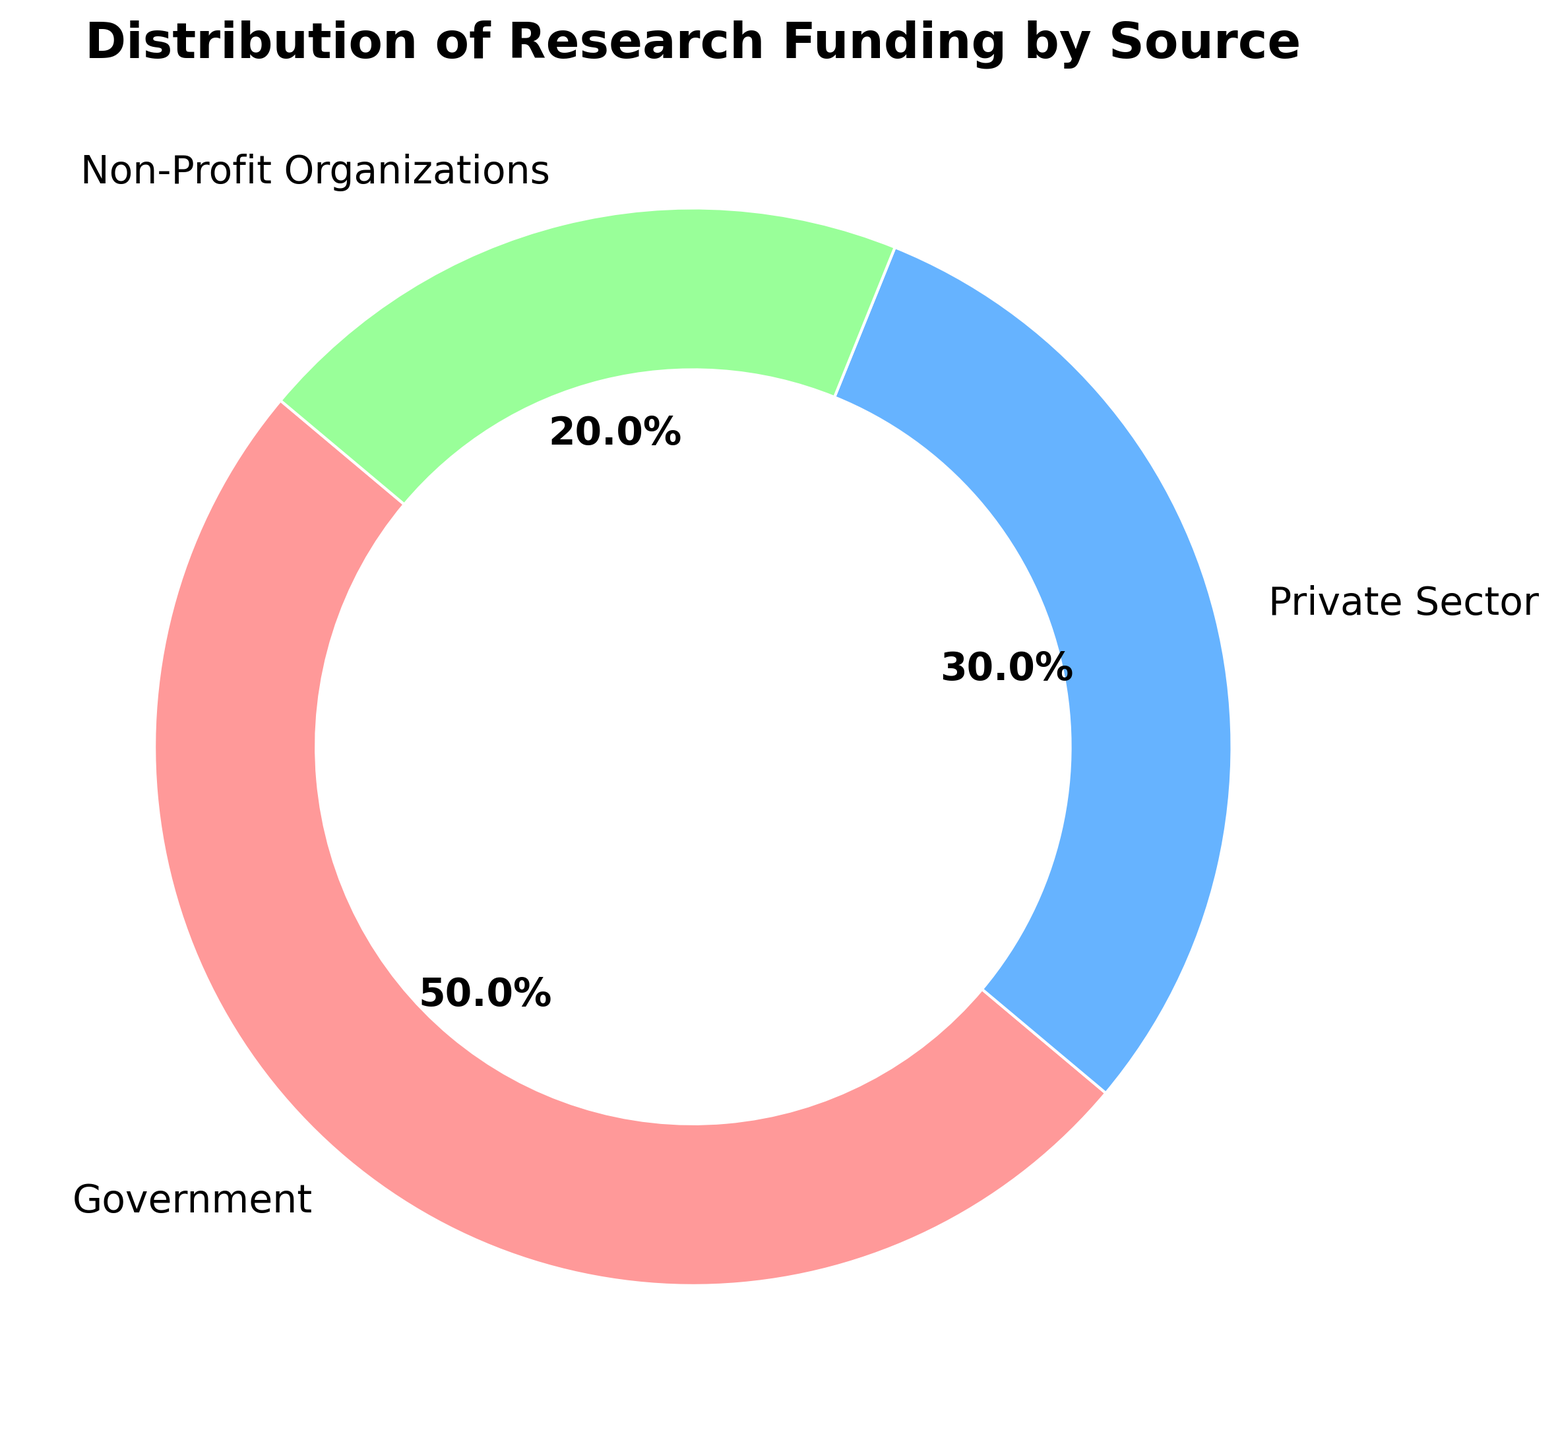What percentage of research funding comes from Government sources? The pie chart clearly shows that the largest portion of the funding, indicated in the color representing Government (most likely red or another strong color), is labeled as 50%.
Answer: 50% How much greater is the percentage of funding from Government compared to Non-Profit Organizations? From the pie chart, the Government funding is 50%, and Non-Profit Organizations funding is 20%. Subtracting the smaller percentage from the larger gives 50% - 20%.
Answer: 30% Which funding source has the smallest contribution, and what is its percentage? By observing the pie chart, we can see that the smallest segment, indicated by its size, represents Non-Profit Organizations, which is labeled as 20%.
Answer: Non-Profit Organizations, 20% If the total funding is $1,000,000, how much is contributed by the Private Sector? The pie chart shows the Private Sector contributes 30% of the funding. To find the amount: \(1{,}000{,}000 \times 0.30\).
Answer: $300,000 What is the combined percentage of funding from Private Sector and Non-Profit Organizations? Adding the percentages from the pie chart for Private Sector (30%) and Non-Profit Organizations (20%) results in 30% + 20%.
Answer: 50% Which sector has the highest funding, and by how much more is it than the Private Sector? From the pie chart, the Government has the highest funding at 50%. The Private Sector is at 30%. The difference is 50% - 30%.
Answer: Government, 20% What color visually represents the Non-Profit Organizations funding on the pie chart? By looking at the pie chart and identifying the segments, the Non-Profit Organizations segment (20%) will be marked with a specific color, likely green based on typical color-coding conventions.
Answer: Green If the total allocation for Government funding doubles next year, what percentage of the total will it then represent, assuming the total funding pool remains the same? The current Government funding is 50% of the total. If the amount doubles, it will then represent \(50\% \times 2 = 100\%\). This unrealistic scenario indicates the entire funding would be from the Government, but percentages need to remain feasible (i.e., recalculating might be necessary).
Answer: Impossible scenario without recalculating overall distribution What is the average percentage contribution of each funding source? To find the average, sum all the percentages and divide by the number of sources: \(\frac{50\% + 30\% + 20\%}{3}\).
Answer: 33.33% If an additional funding of 10% is secured from an unlisted source, what would be the new total percentage contribution for each existing source, assuming equal redistribution? To solve this, we first distribute the 10% equally among the three sources, adding \(\frac{10\%}{3} = 3.33\%\) to each: Government (50% + 3.33%), Private Sector (30% + 3.33%), Non-Profit Organizations (20% + 3.33%).
Answer: Government 53.33%, Private Sector 33.33%, Non-Profit Organizations 23.33% 